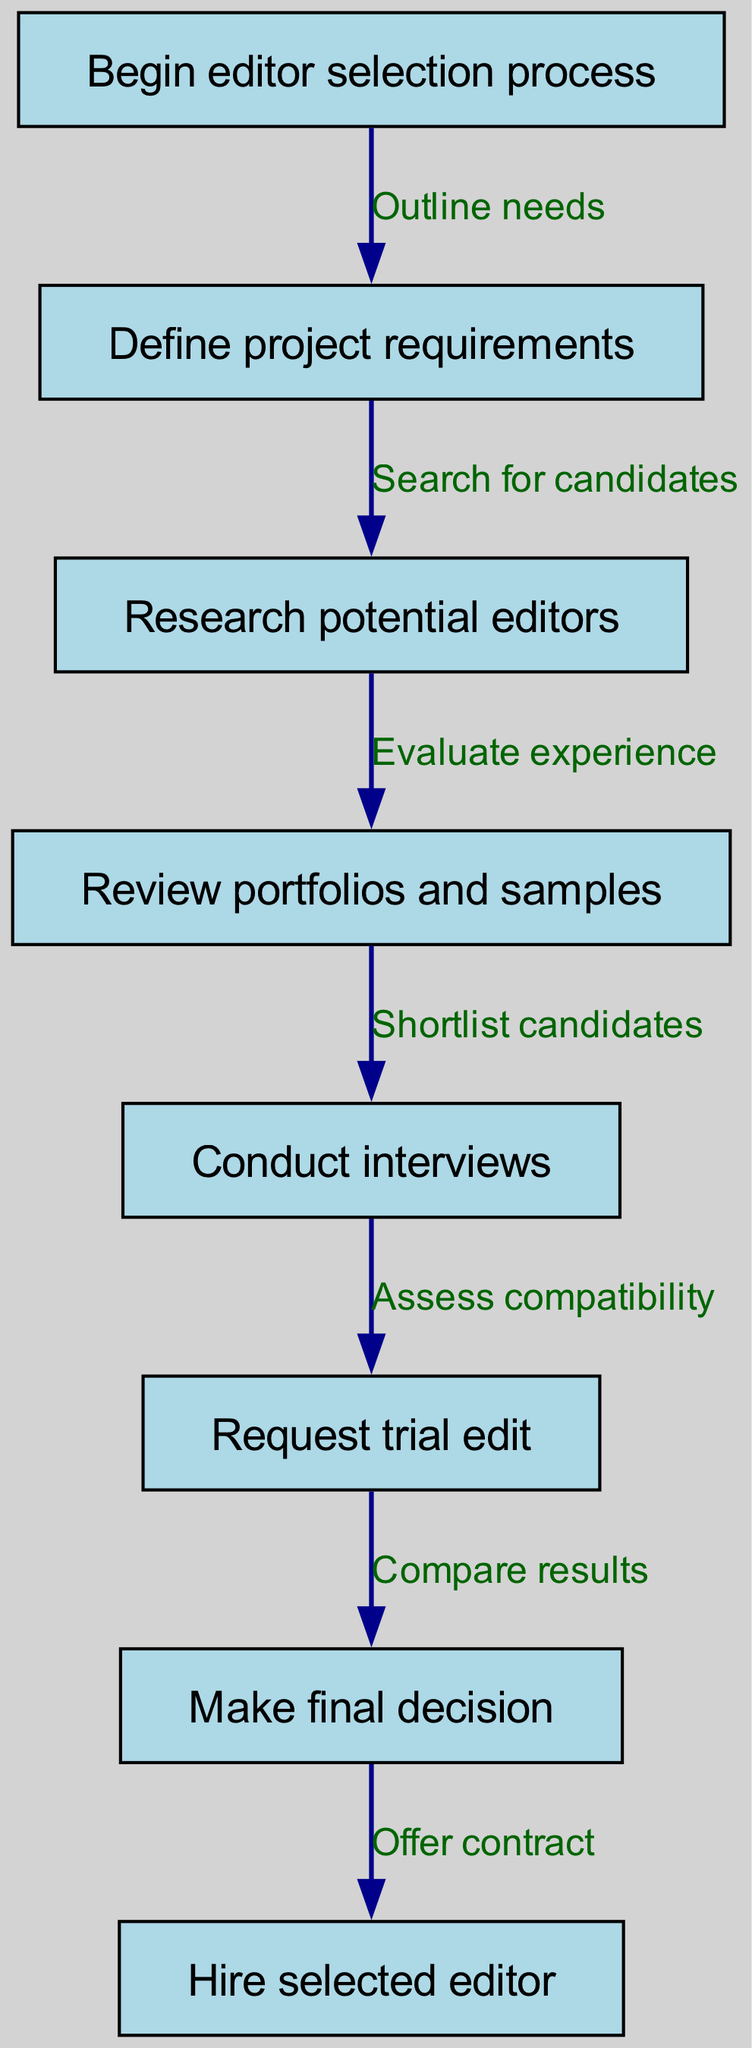What is the first step in the editor selection process? The diagram starts with the node labeled "Begin editor selection process." This clearly indicates that the process begins at this specific step.
Answer: Begin editor selection process How many nodes are in the diagram? By counting the number of unique node entries listed, there are a total of eight nodes represented in the diagram.
Answer: 8 What follows after defining project requirements? The flow of the diagram shows that after defining project requirements, the next step is "Research potential editors." This is indicated by the directed edge connecting the two nodes.
Answer: Research potential editors Which step involves reviewing editor portfolios? The step labeled "Review portfolios and samples" specifically indicates the action related to examining the work of potential editors, making it the correct answer.
Answer: Review portfolios and samples What is the final decision point in the selection process? The diagram indicates that after all preceding steps, the final decision is made in the step labeled "Make final decision," as per the directed flow.
Answer: Make final decision How many steps are there from research to trial edit? In tracing the steps, there is a direct path from "Research potential editors" to "Request trial edit," showing that there are two distinct steps in that flow: "Research potential editors" then "Request trial edit."
Answer: 2 What action is taken after conducting interviews? Following the "Conduct interviews" step, the next action specified in the diagram is to "Request trial edit." This shows the logical progression from interviewing to requesting a practical demonstration.
Answer: Request trial edit What is the relationship between "Compare results" and "Request trial edit"? The diagram illustrates that "Compare results" comes after "Request trial edit," signifying a direct progression that assesses the outcomes of the trial edit.
Answer: Assess compatibility What does the edge from "Decision" to "Hire" signify? The edge labeled "Offer contract" indicates that the action taken after making a decision is to hire the selected editor, marking the conclusion of the selection process.
Answer: Offer contract 